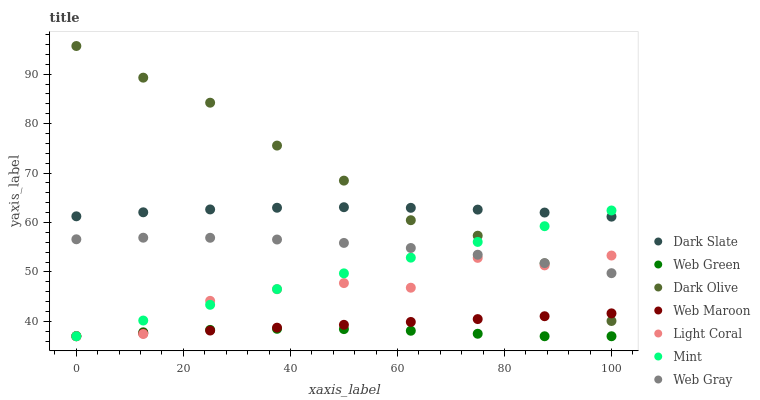Does Web Green have the minimum area under the curve?
Answer yes or no. Yes. Does Dark Olive have the maximum area under the curve?
Answer yes or no. Yes. Does Web Maroon have the minimum area under the curve?
Answer yes or no. No. Does Web Maroon have the maximum area under the curve?
Answer yes or no. No. Is Mint the smoothest?
Answer yes or no. Yes. Is Light Coral the roughest?
Answer yes or no. Yes. Is Dark Olive the smoothest?
Answer yes or no. No. Is Dark Olive the roughest?
Answer yes or no. No. Does Web Maroon have the lowest value?
Answer yes or no. Yes. Does Dark Olive have the lowest value?
Answer yes or no. No. Does Dark Olive have the highest value?
Answer yes or no. Yes. Does Web Maroon have the highest value?
Answer yes or no. No. Is Web Green less than Dark Olive?
Answer yes or no. Yes. Is Dark Slate greater than Web Maroon?
Answer yes or no. Yes. Does Light Coral intersect Mint?
Answer yes or no. Yes. Is Light Coral less than Mint?
Answer yes or no. No. Is Light Coral greater than Mint?
Answer yes or no. No. Does Web Green intersect Dark Olive?
Answer yes or no. No. 